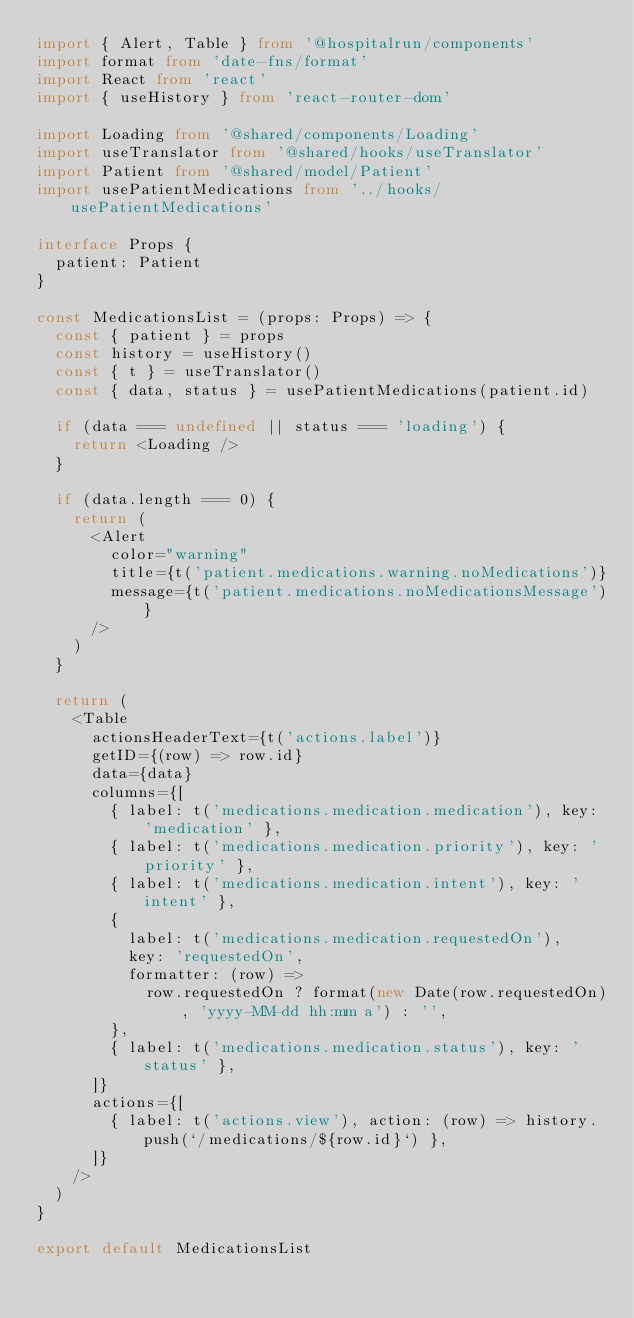<code> <loc_0><loc_0><loc_500><loc_500><_TypeScript_>import { Alert, Table } from '@hospitalrun/components'
import format from 'date-fns/format'
import React from 'react'
import { useHistory } from 'react-router-dom'

import Loading from '@shared/components/Loading'
import useTranslator from '@shared/hooks/useTranslator'
import Patient from '@shared/model/Patient'
import usePatientMedications from '../hooks/usePatientMedications'

interface Props {
  patient: Patient
}

const MedicationsList = (props: Props) => {
  const { patient } = props
  const history = useHistory()
  const { t } = useTranslator()
  const { data, status } = usePatientMedications(patient.id)

  if (data === undefined || status === 'loading') {
    return <Loading />
  }

  if (data.length === 0) {
    return (
      <Alert
        color="warning"
        title={t('patient.medications.warning.noMedications')}
        message={t('patient.medications.noMedicationsMessage')}
      />
    )
  }

  return (
    <Table
      actionsHeaderText={t('actions.label')}
      getID={(row) => row.id}
      data={data}
      columns={[
        { label: t('medications.medication.medication'), key: 'medication' },
        { label: t('medications.medication.priority'), key: 'priority' },
        { label: t('medications.medication.intent'), key: 'intent' },
        {
          label: t('medications.medication.requestedOn'),
          key: 'requestedOn',
          formatter: (row) =>
            row.requestedOn ? format(new Date(row.requestedOn), 'yyyy-MM-dd hh:mm a') : '',
        },
        { label: t('medications.medication.status'), key: 'status' },
      ]}
      actions={[
        { label: t('actions.view'), action: (row) => history.push(`/medications/${row.id}`) },
      ]}
    />
  )
}

export default MedicationsList
</code> 